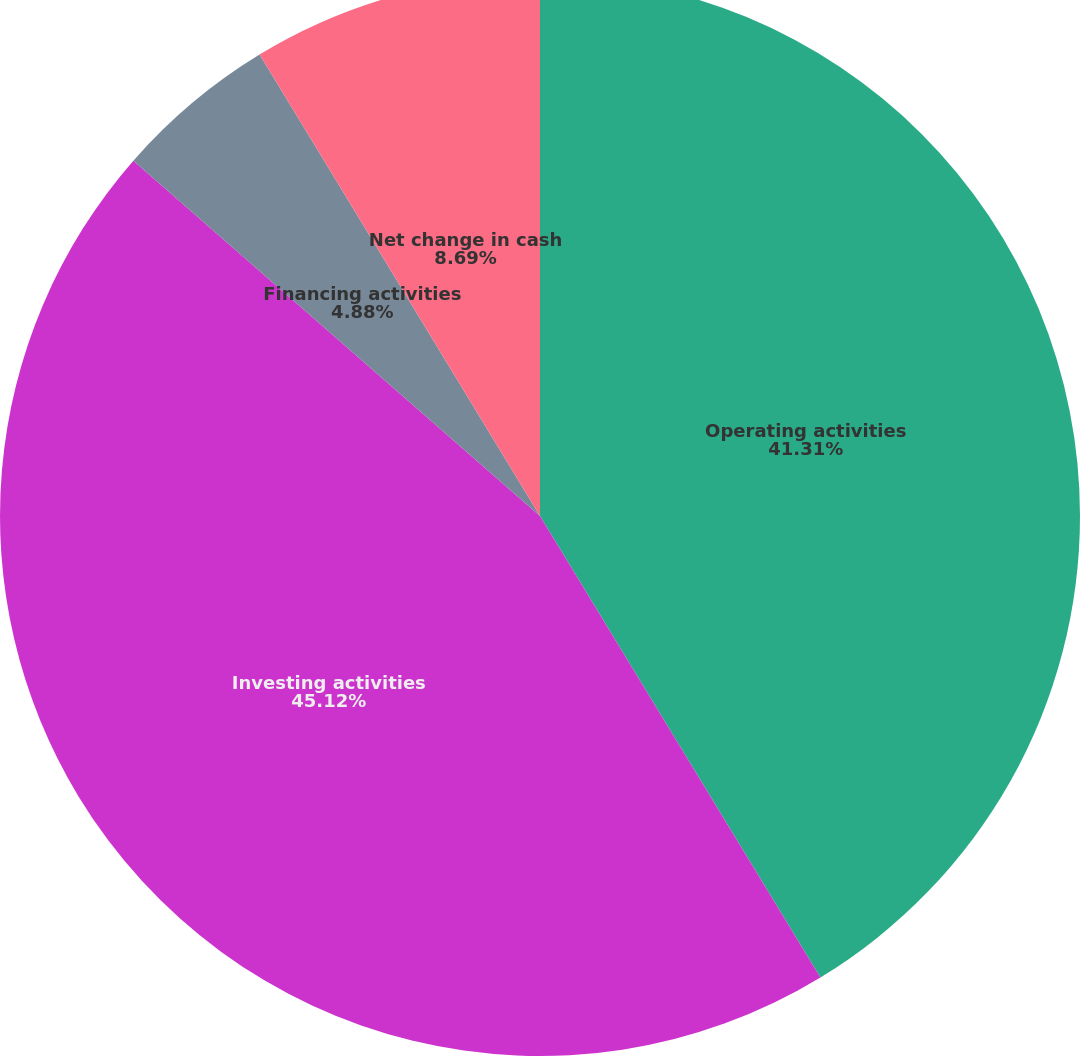<chart> <loc_0><loc_0><loc_500><loc_500><pie_chart><fcel>Operating activities<fcel>Investing activities<fcel>Financing activities<fcel>Net change in cash<nl><fcel>41.31%<fcel>45.12%<fcel>4.88%<fcel>8.69%<nl></chart> 